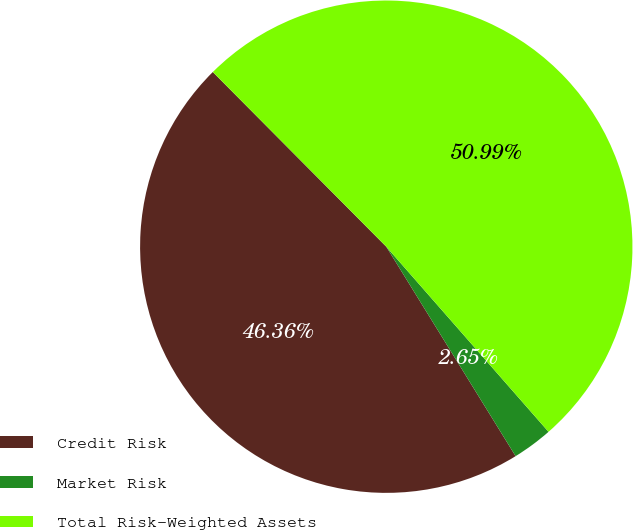<chart> <loc_0><loc_0><loc_500><loc_500><pie_chart><fcel>Credit Risk<fcel>Market Risk<fcel>Total Risk-Weighted Assets<nl><fcel>46.36%<fcel>2.65%<fcel>50.99%<nl></chart> 